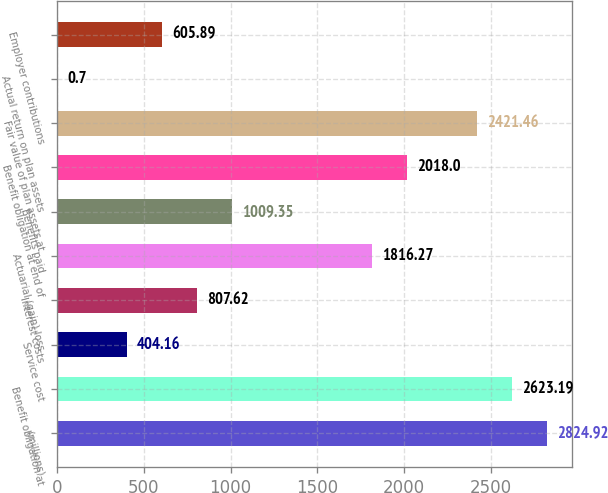<chart> <loc_0><loc_0><loc_500><loc_500><bar_chart><fcel>(millions)<fcel>Benefit obligation at<fcel>Service cost<fcel>Interest costs<fcel>Actuarial (gain) loss<fcel>Benefits paid<fcel>Benefit obligation at end of<fcel>Fair value of plan assets at<fcel>Actual return on plan assets<fcel>Employer contributions<nl><fcel>2824.92<fcel>2623.19<fcel>404.16<fcel>807.62<fcel>1816.27<fcel>1009.35<fcel>2018<fcel>2421.46<fcel>0.7<fcel>605.89<nl></chart> 